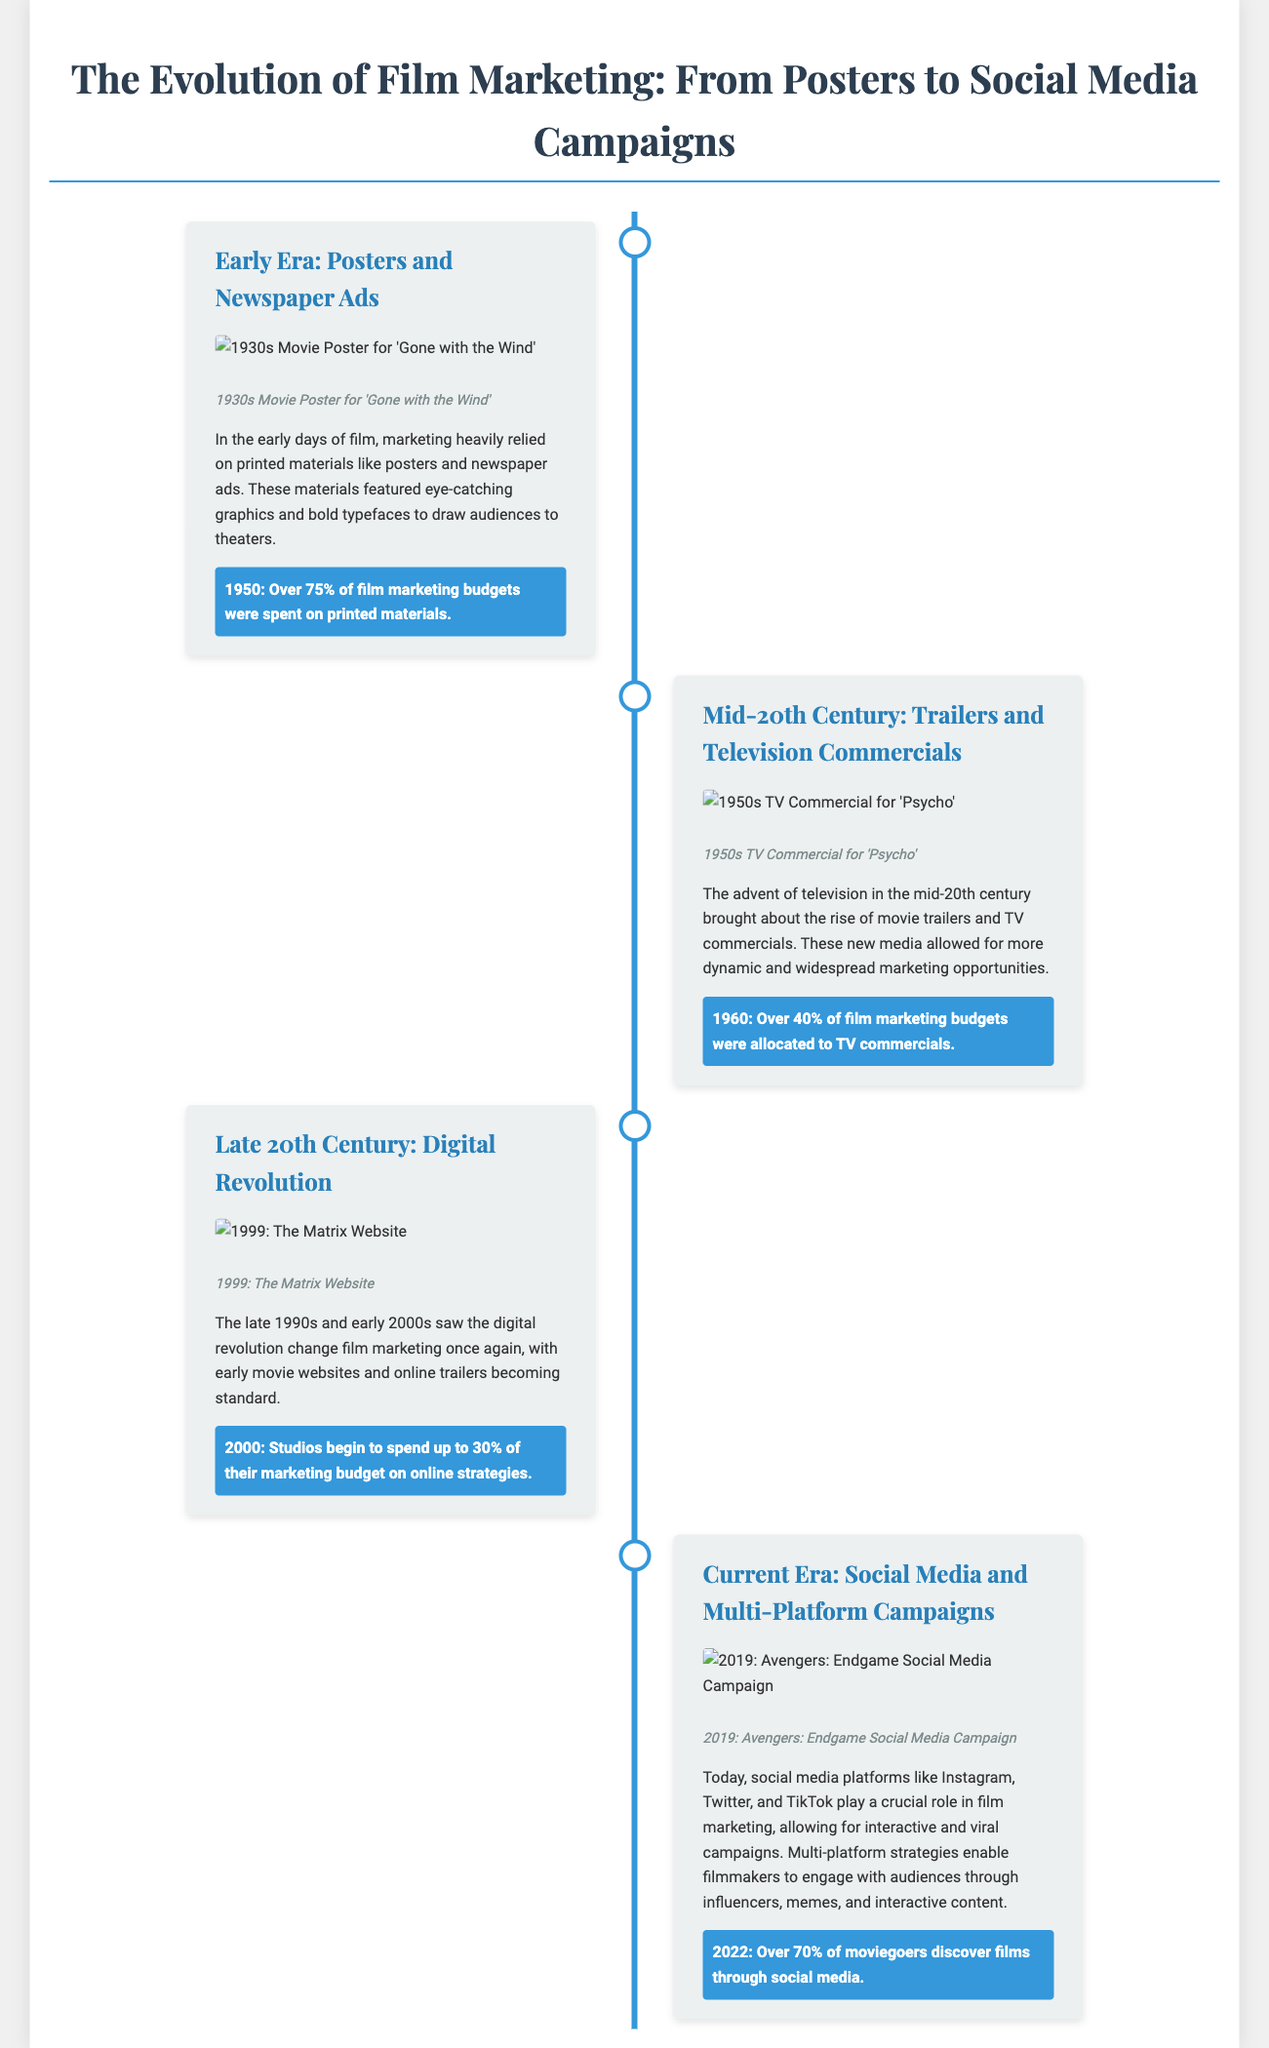what was the first major film marketing method? The document states that the early days of film marketing relied heavily on printed materials like posters and newspaper ads.
Answer: Posters and Newspaper Ads what year did studios spend over 75% of their marketing budgets on printed materials? The document indicates that this occurred in 1950.
Answer: 1950 which film had a TV commercial featured in the mid-20th century section? The document mentions 'Psycho' as the film for which a TV commercial was made.
Answer: Psycho what percentage of film marketing budgets were allocated to TV commercials in 1960? The document notes that over 40% of film marketing budgets were spent on TV commercials in that year.
Answer: Over 40% what significant change occurred in the late 1990s regarding film marketing? The document points out the rise of early movie websites and online trailers as part of the digital revolution.
Answer: Digital Revolution which film's marketing is associated with a social media campaign in 2019? According to the document, 'Avengers: Endgame' is the film linked to that campaign.
Answer: Avengers: Endgame what notable statistic about moviegoers is mentioned for 2022? The document states that over 70% of moviegoers discover films through social media.
Answer: Over 70% what type of marketing materials were used in the early era of film marketing? The early era relied on printed materials, specifically posters and newspaper ads.
Answer: Printed Materials how did film marketing strategies evolve in the current era? The document explains that film marketing now involves social media and multi-platform campaigns for engagement.
Answer: Social Media and Multi-Platform Campaigns 